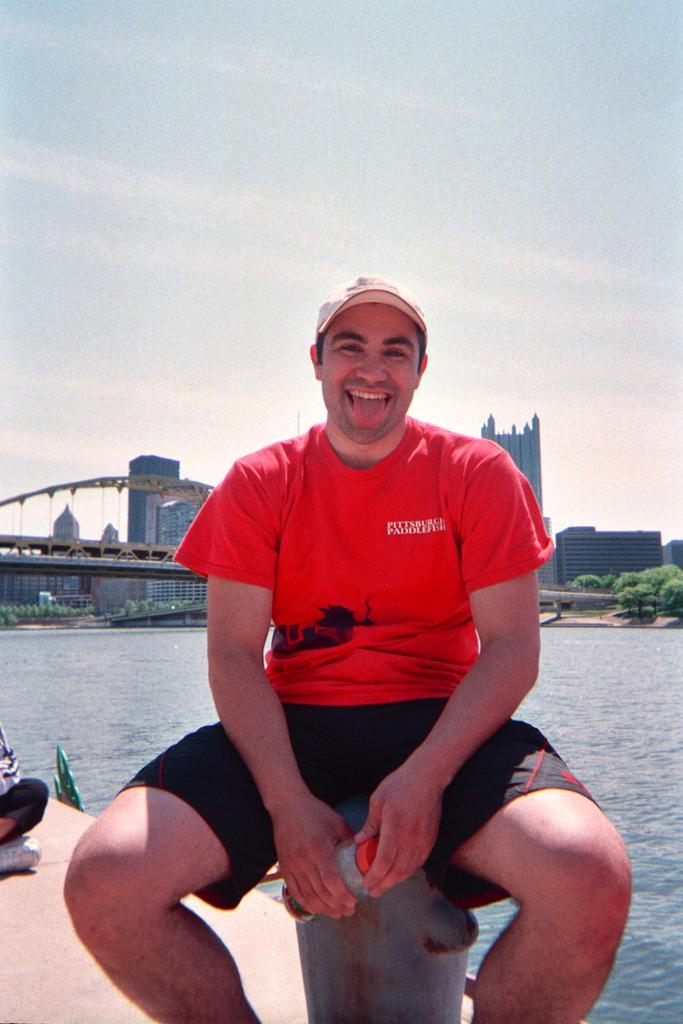What is the person in the image doing? The person is sitting on a small pole in the image. What is the person wearing on their head? The person is wearing a cap. What object is the person holding in their hand? The person is holding a bottle in their hand. What can be seen in the background of the image? There is a lake, a bridge, trees, buildings, and the sky visible in the background of the image. What is the person's sister feeling in the image? There is no indication of a sister or any emotions in the image. 